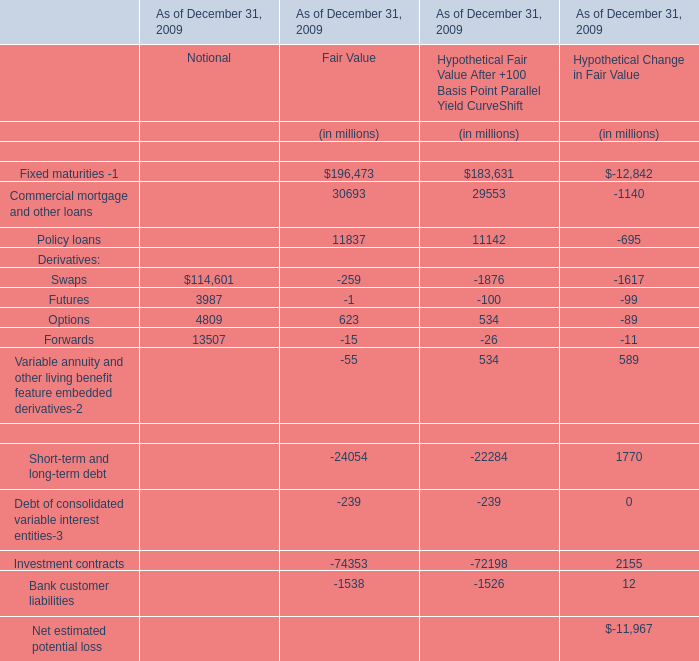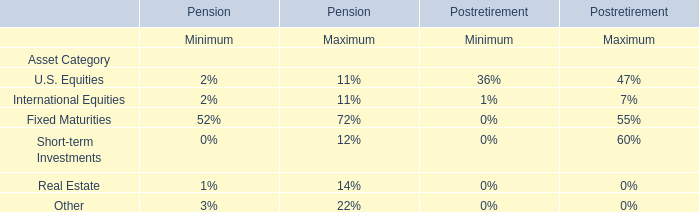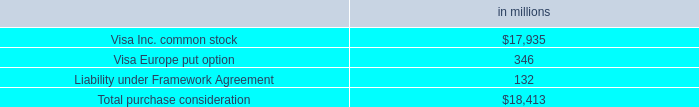What do all elements for Notional sum up without those elements smaller than 10000 , in 2009? (in million) 
Computations: (114601 + 13507)
Answer: 128108.0. 